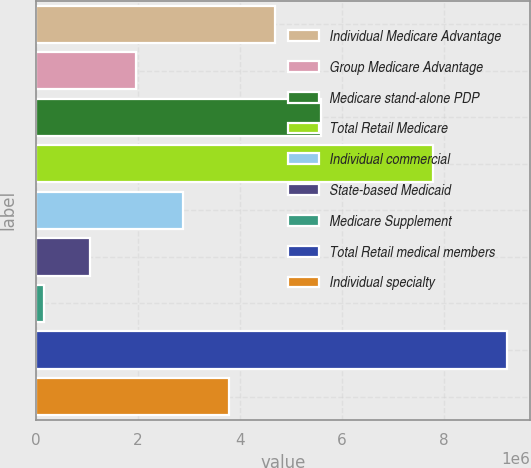Convert chart. <chart><loc_0><loc_0><loc_500><loc_500><bar_chart><fcel>Individual Medicare Advantage<fcel>Group Medicare Advantage<fcel>Medicare stand-alone PDP<fcel>Total Retail Medicare<fcel>Individual commercial<fcel>State-based Medicaid<fcel>Medicare Supplement<fcel>Total Retail medical members<fcel>Individual specialty<nl><fcel>4.6927e+06<fcel>1.97224e+06<fcel>5.59952e+06<fcel>7.7954e+06<fcel>2.87906e+06<fcel>1.06542e+06<fcel>158600<fcel>9.2268e+06<fcel>3.78588e+06<nl></chart> 